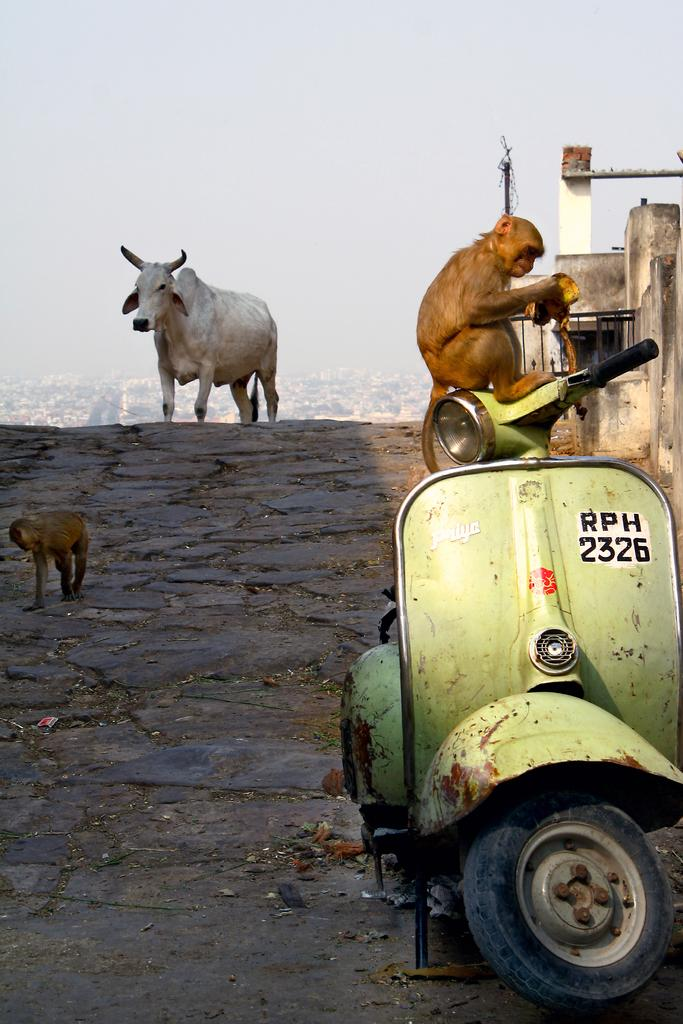What types of living organisms can be seen in the image? There are animals in the image. What mode of transportation is present in the image? There is a two-wheeler in the image. What type of path is visible in the image? There is a footpath in the image. What type of structure is present in the image? There is a wall in the image. What type of vertical structure is present in the image? There is a pole in the image. What part of the natural environment is visible in the image? The sky is visible in the image. What type of muscle is being exercised by the animals in the image? There are no animals exercising muscles in the image; it simply shows animals and other objects. What type of disease can be seen affecting the two-wheeler in the image? There is no disease present in the image; it is a two-wheeler and other objects. 